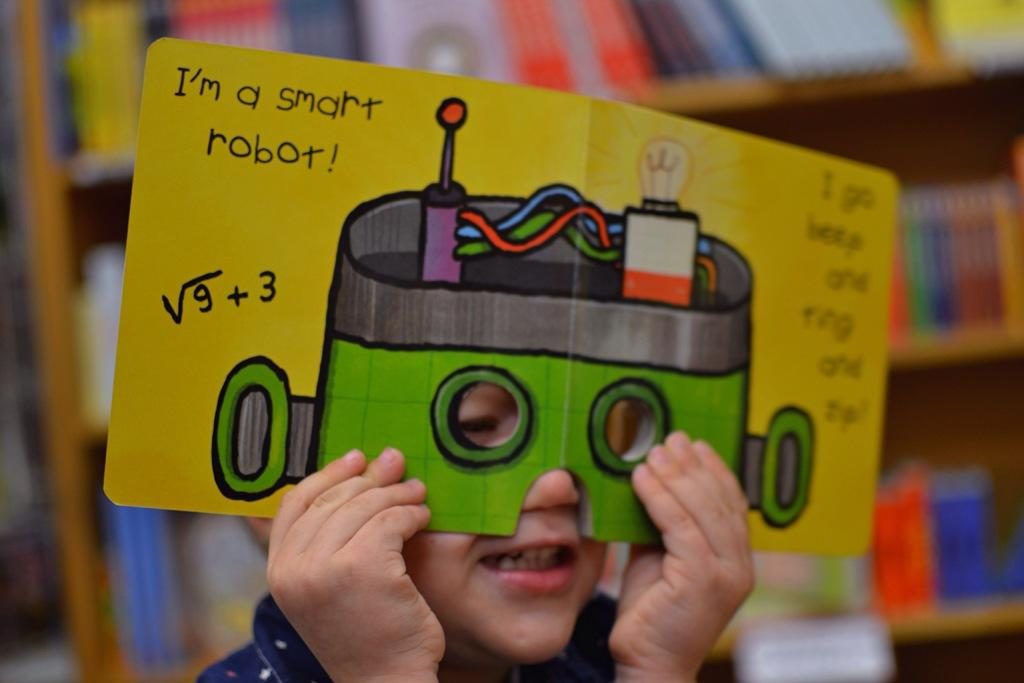Who is in the image? There is a boy in the image. What is the boy wearing on his face? The boy is wearing a mask. What can be seen on the mask? The mask has paintings and texts on it. How is the boy holding the mask? The boy is holding the mask with both hands. What can be observed about the background in the image? The background of the boy is blurred. What type of mountain can be seen in the background of the image? There is no mountain visible in the background of the image; the background is blurred. What topic is the boy discussing with his friend in the image? There is no indication of a discussion or a friend in the image; it only shows a boy holding a mask. 